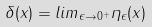Convert formula to latex. <formula><loc_0><loc_0><loc_500><loc_500>\delta ( x ) = l i m _ { \epsilon \rightarrow 0 ^ { + } } \eta _ { \epsilon } ( x )</formula> 